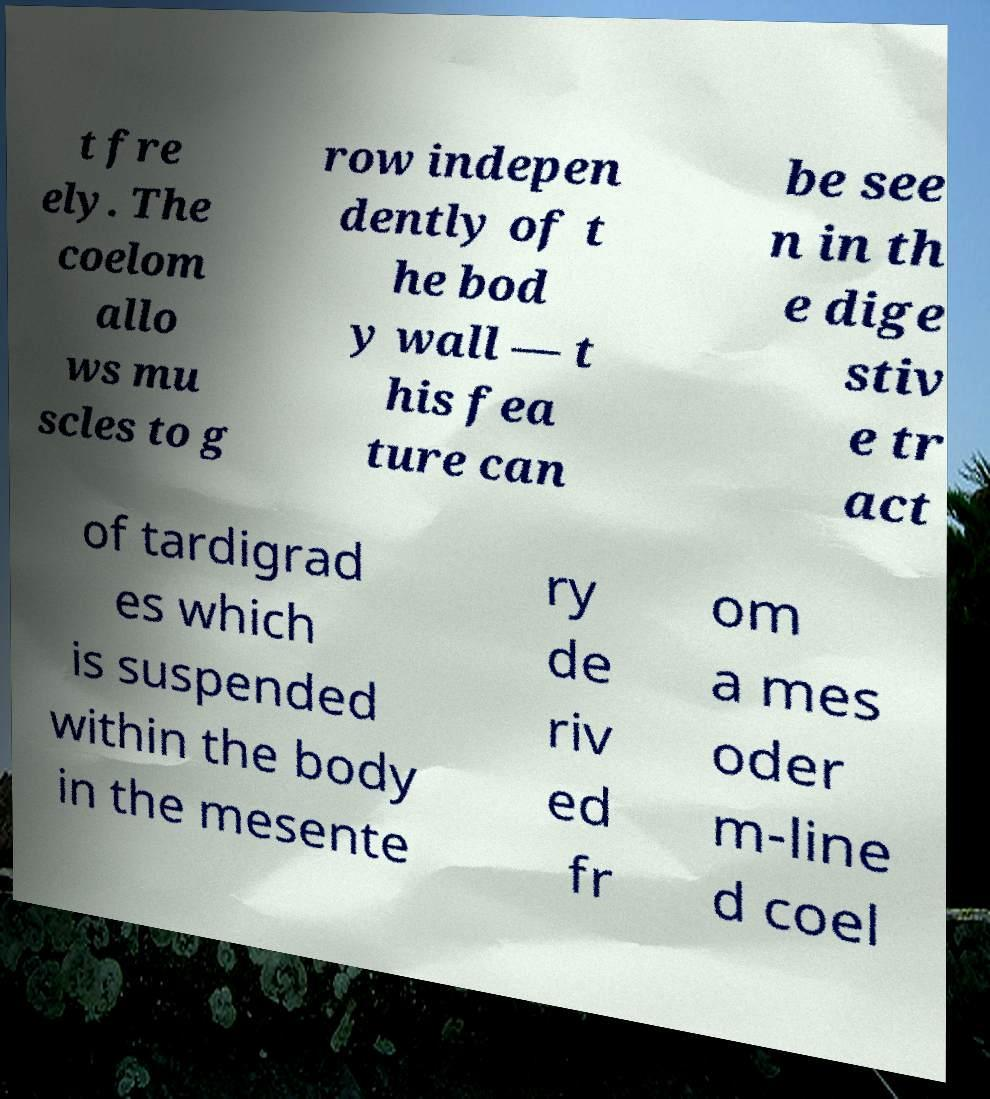Can you read and provide the text displayed in the image?This photo seems to have some interesting text. Can you extract and type it out for me? t fre ely. The coelom allo ws mu scles to g row indepen dently of t he bod y wall — t his fea ture can be see n in th e dige stiv e tr act of tardigrad es which is suspended within the body in the mesente ry de riv ed fr om a mes oder m-line d coel 